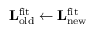<formula> <loc_0><loc_0><loc_500><loc_500>L _ { o l d } ^ { f i t } \leftarrow L _ { n e w } ^ { f i t }</formula> 